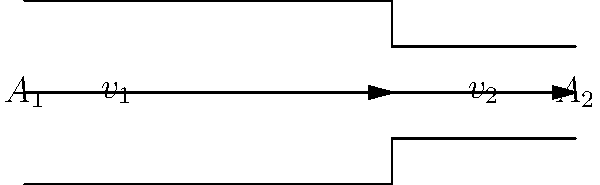Blood flows through an artery that narrows from a cross-sectional area of $A_1 = 2.0 \text{ cm}^2$ to $A_2 = 1.0 \text{ cm}^2$. If the initial velocity of the blood is $v_1 = 20 \text{ cm/s}$, what is the velocity $v_2$ in the narrowed section of the artery? To solve this problem, we'll use the continuity equation, which states that the volume flow rate remains constant in a closed system:

1) The continuity equation: $A_1v_1 = A_2v_2$

2) We know:
   $A_1 = 2.0 \text{ cm}^2$
   $A_2 = 1.0 \text{ cm}^2$
   $v_1 = 20 \text{ cm/s}$

3) Substitute the known values into the continuity equation:
   $(2.0 \text{ cm}^2)(20 \text{ cm/s}) = (1.0 \text{ cm}^2)(v_2)$

4) Simplify the left side:
   $40 \text{ cm}^3/\text{s} = 1.0 \text{ cm}^2 \cdot v_2$

5) Solve for $v_2$:
   $v_2 = \frac{40 \text{ cm}^3/\text{s}}{1.0 \text{ cm}^2} = 40 \text{ cm/s}$

Thus, the velocity in the narrowed section of the artery is 40 cm/s.
Answer: $40 \text{ cm/s}$ 